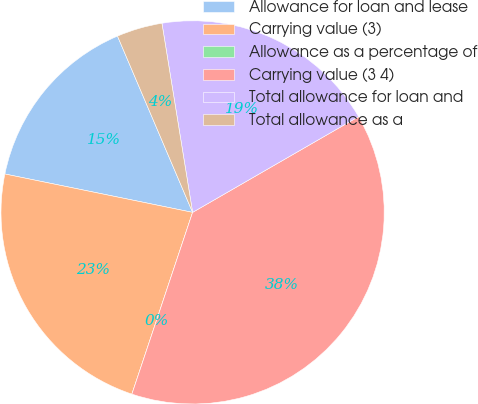Convert chart. <chart><loc_0><loc_0><loc_500><loc_500><pie_chart><fcel>Allowance for loan and lease<fcel>Carrying value (3)<fcel>Allowance as a percentage of<fcel>Carrying value (3 4)<fcel>Total allowance for loan and<fcel>Total allowance as a<nl><fcel>15.38%<fcel>23.08%<fcel>0.0%<fcel>38.46%<fcel>19.23%<fcel>3.85%<nl></chart> 